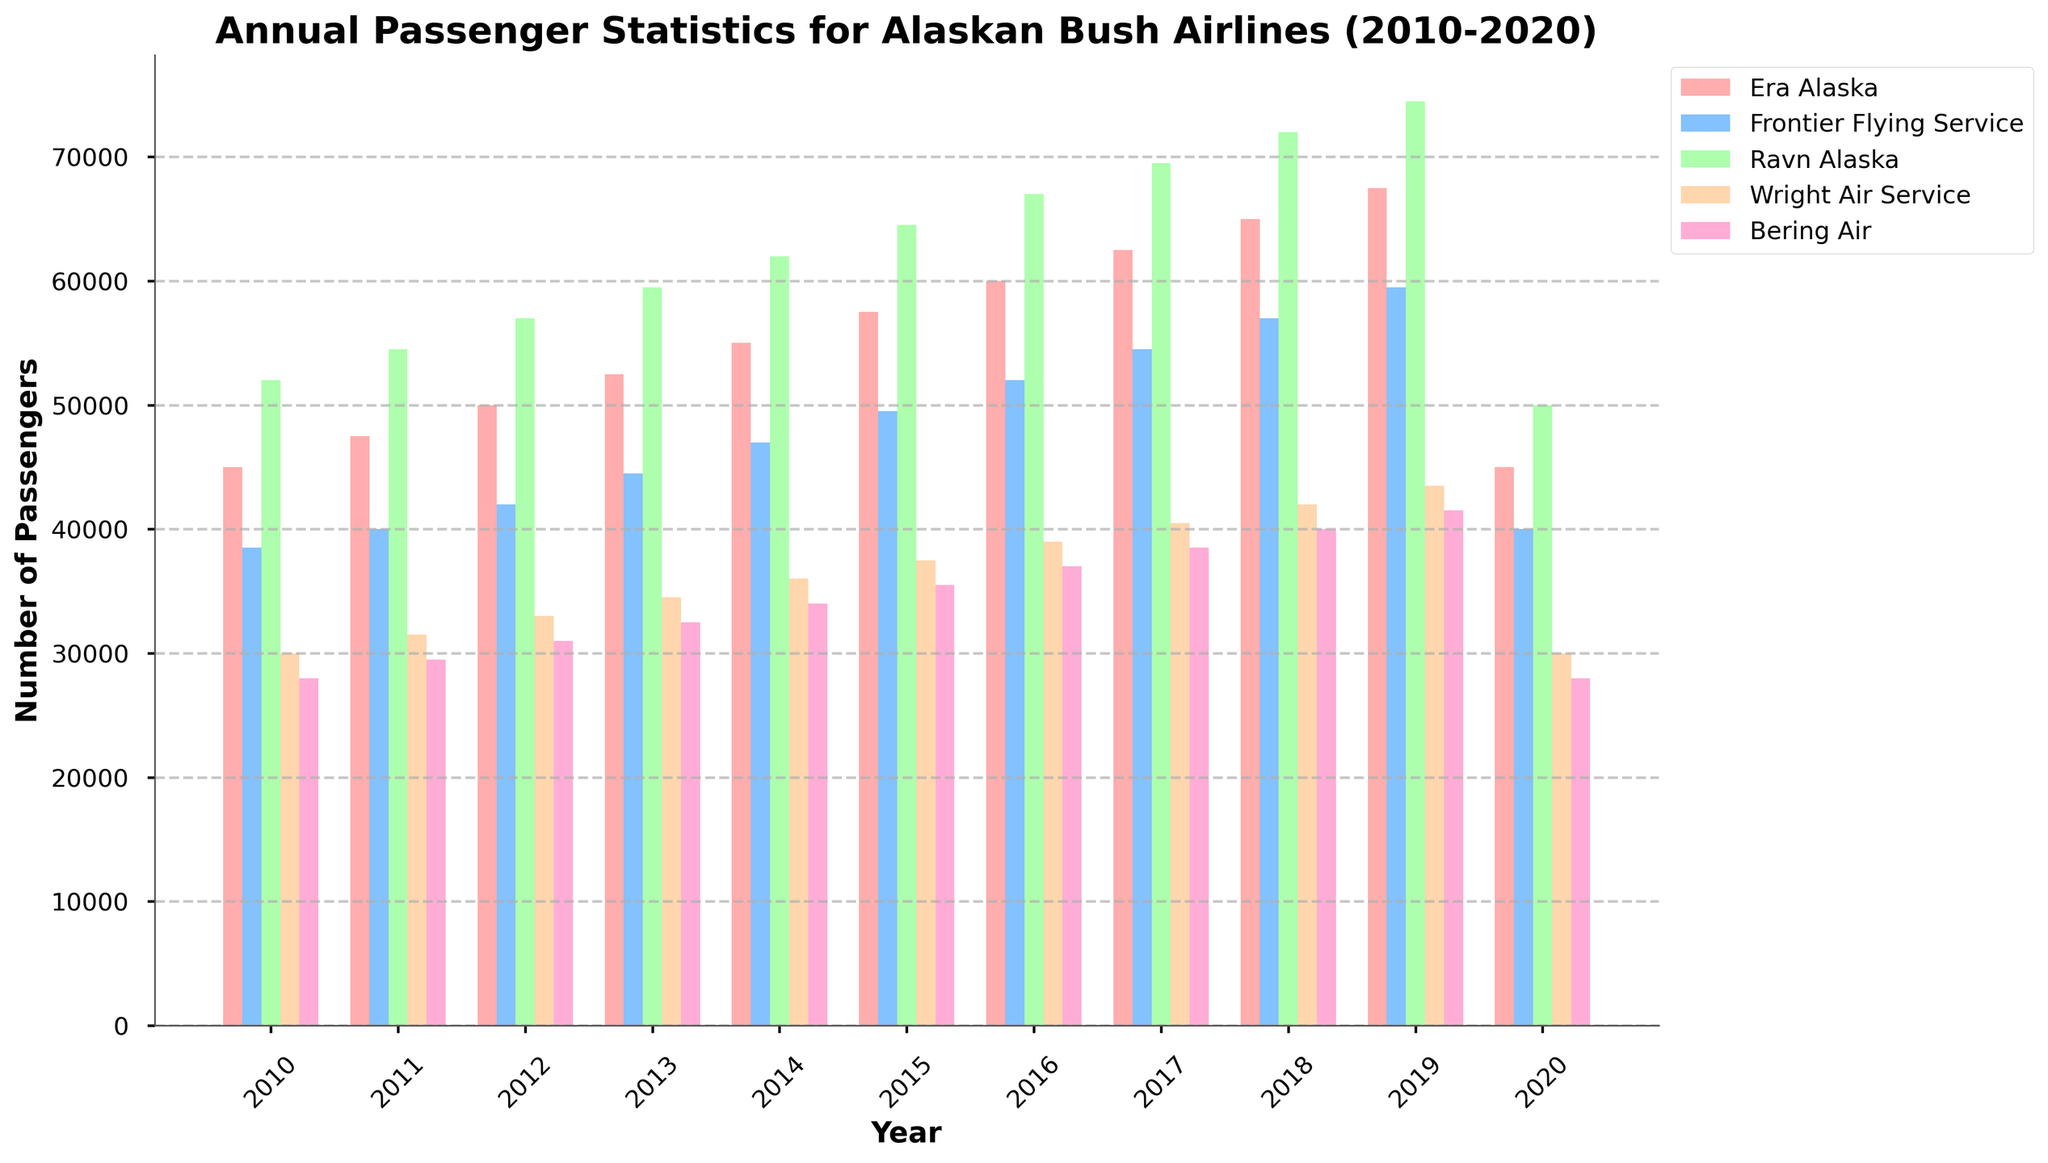What was the total number of passengers for Era Alaska and Bering Air combined in 2015? First, find the number of passengers for Era Alaska in 2015: 57,500. Next, find the number of passengers for Bering Air in 2015: 35,500. Then, sum these two values: 57,500 + 35,500 = 93,000
Answer: 93,000 Which airline had the highest number of passengers in 2017? Look at the bars for 2017 and compare their heights. The tallest bar corresponds to Ravn Alaska with 69,500 passengers
Answer: Ravn Alaska By how much did Frontier Flying Service's passenger count increase from 2010 to 2019? First, find Frontier Flying Service's passenger count in 2010: 38,500. Then find the count in 2019: 59,500. Subtract the 2010 value from the 2019 value: 59,500 - 38,500 = 21,000
Answer: 21,000 Which airline experienced the largest drop in passengers from 2019 to 2020? Compare the passenger counts for all airlines in 2019 and 2020. The airline with the largest drop is Ravn Alaska, from 74,500 in 2019 to 50,000 in 2020, a drop of 24,500
Answer: Ravn Alaska What is the average number of passengers for Wright Air Service from 2010 to 2020? Sum the passengers for Wright Air Service from 2010 to 2020: 30,000 + 31,500 + 33,000 + 34,500 + 36,000 + 37,500 + 39,000 + 40,500 + 42,000 + 43,500 + 30,000 = 398,500. Divide by the number of years (11): 398,500 / 11 ≈ 36,227
Answer: 36,227 During which year did Bering Air have the lowest number of passengers? Look at the bars for Bering Air and identify the year with the shortest bar. The lowest number of passengers is in 2010 and 2020, both with 28,000 passengers
Answer: 2010 and 2020 Which airlines had an equal number of passengers in 2020? Look at the bars for 2020 and compare their heights. Both Era Alaska and Wright Air Service had 30,000 passengers in 2020
Answer: Era Alaska and Wright Air Service How many more passengers did Ravn Alaska have than Era Alaska in 2018? Find Ravn Alaska's passengers in 2018: 72,000. Then find Era Alaska's passengers in 2018: 65,000. Subtract Era Alaska's count from Ravn Alaska's: 72,000 - 65,000 = 7,000
Answer: 7,000 What was the percentage increase in passengers for Frontier Flying Service from 2010 to 2016? Find the passenger count in 2010: 38,500 and in 2016: 52,000. Calculate the absolute increase: 52,000 - 38,500 = 13,500. Then calculate the percentage increase: (13,500 / 38,500) * 100 ≈ 35.06%
Answer: 35.06% In which year did Era Alaska first surpass 60,000 passengers? Look at the bars for Era Alaska and find the first year the bar height exceeds 60,000. This happens in 2016, with 60,000 passengers
Answer: 2016 